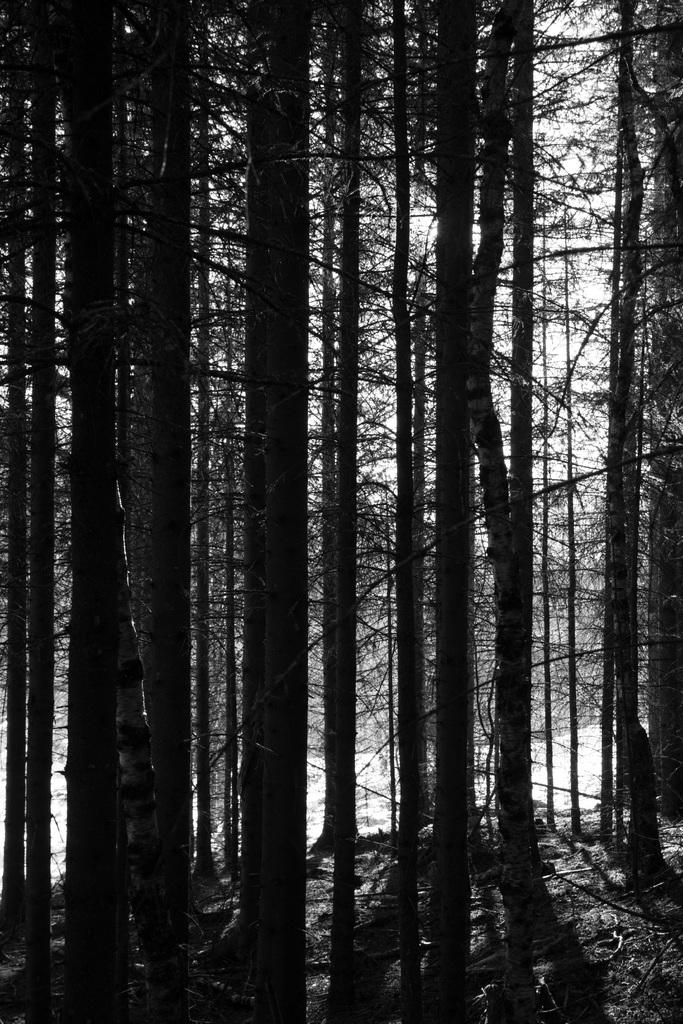What is the color scheme of the image? The image is black and white. What type of natural vegetation can be seen in the image? There are trees in the image. What parts of the trees are visible in the image? There are branches visible in the image. What type of natural environment does the image resemble? The image resembles a forest area. How many oranges can be seen hanging from the branches in the image? There are no oranges present in the image; it features trees with branches. Can you tell me how many lizards are visible on the branches in the image? There are no lizards visible on the branches in the image; it features trees with branches. 